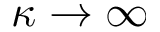Convert formula to latex. <formula><loc_0><loc_0><loc_500><loc_500>\kappa \rightarrow \infty</formula> 